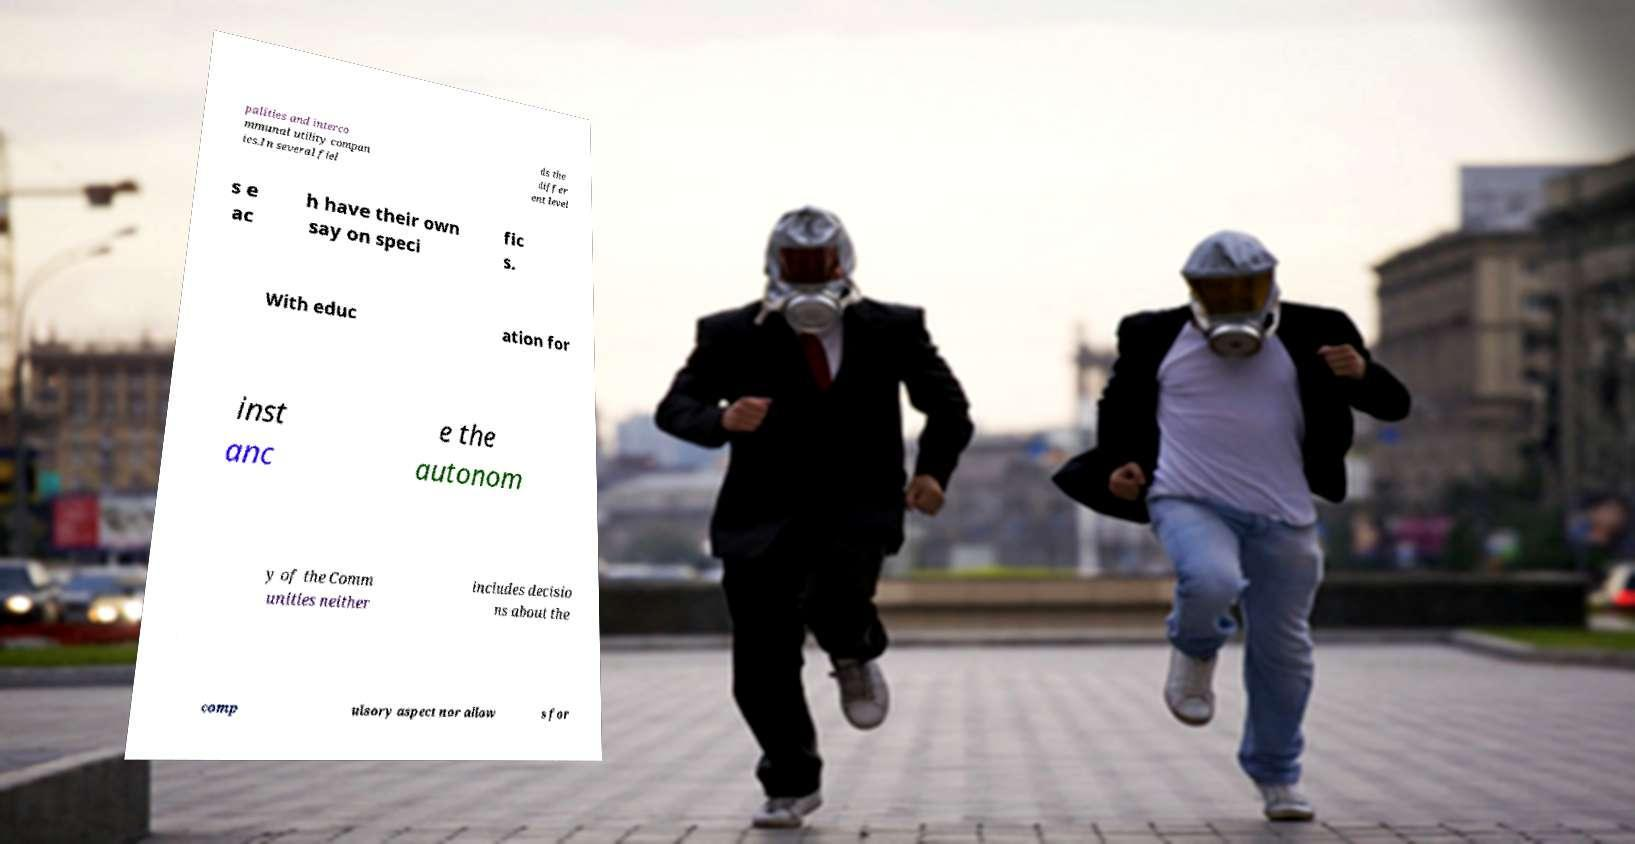There's text embedded in this image that I need extracted. Can you transcribe it verbatim? palities and interco mmunal utility compan ies.In several fiel ds the differ ent level s e ac h have their own say on speci fic s. With educ ation for inst anc e the autonom y of the Comm unities neither includes decisio ns about the comp ulsory aspect nor allow s for 